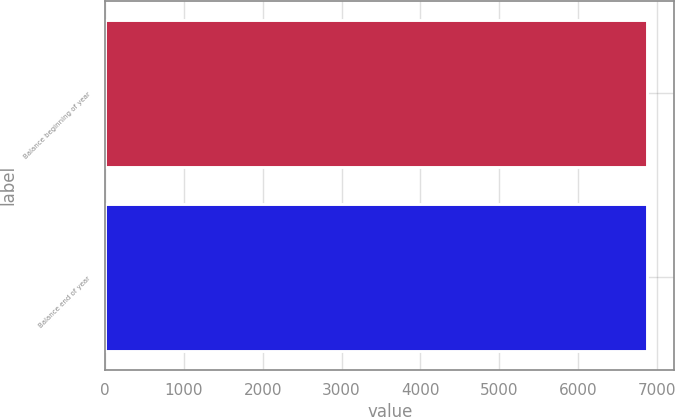<chart> <loc_0><loc_0><loc_500><loc_500><bar_chart><fcel>Balance beginning of year<fcel>Balance end of year<nl><fcel>6878<fcel>6878.1<nl></chart> 